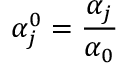<formula> <loc_0><loc_0><loc_500><loc_500>\alpha _ { j } ^ { 0 } = \frac { \alpha _ { j } } { \alpha _ { 0 } }</formula> 